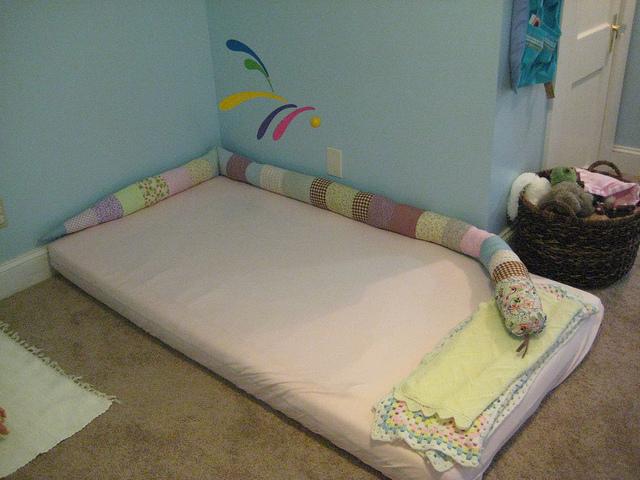What color is the border on the folded blanket?
Give a very brief answer. Yellow. What color is the bed sheet?
Be succinct. Pink. What kind of room is this?
Concise answer only. Bedroom. What color is the wall?
Write a very short answer. Blue. 